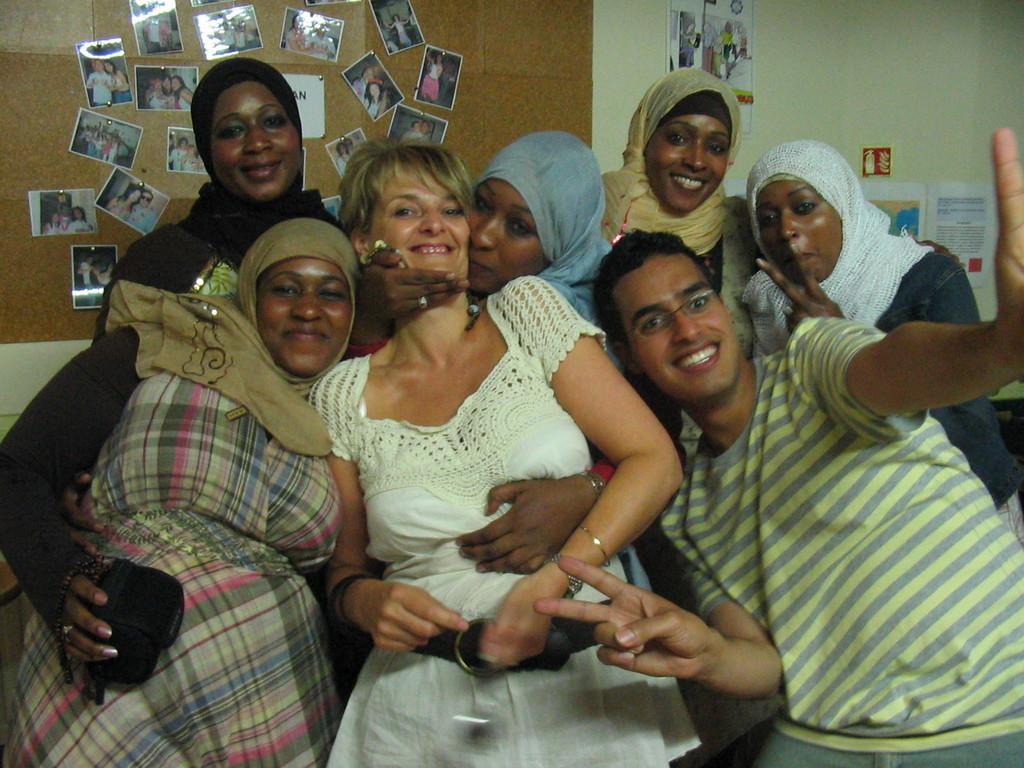Describe this image in one or two sentences. In this picture I can see in the middle a woman is standing and smiling, she wore white color dress. On the right side a man is raising his two hands and smiling, he wore t-shirt. Beside him there are women smiling, behind them there are photographs on the wall. 